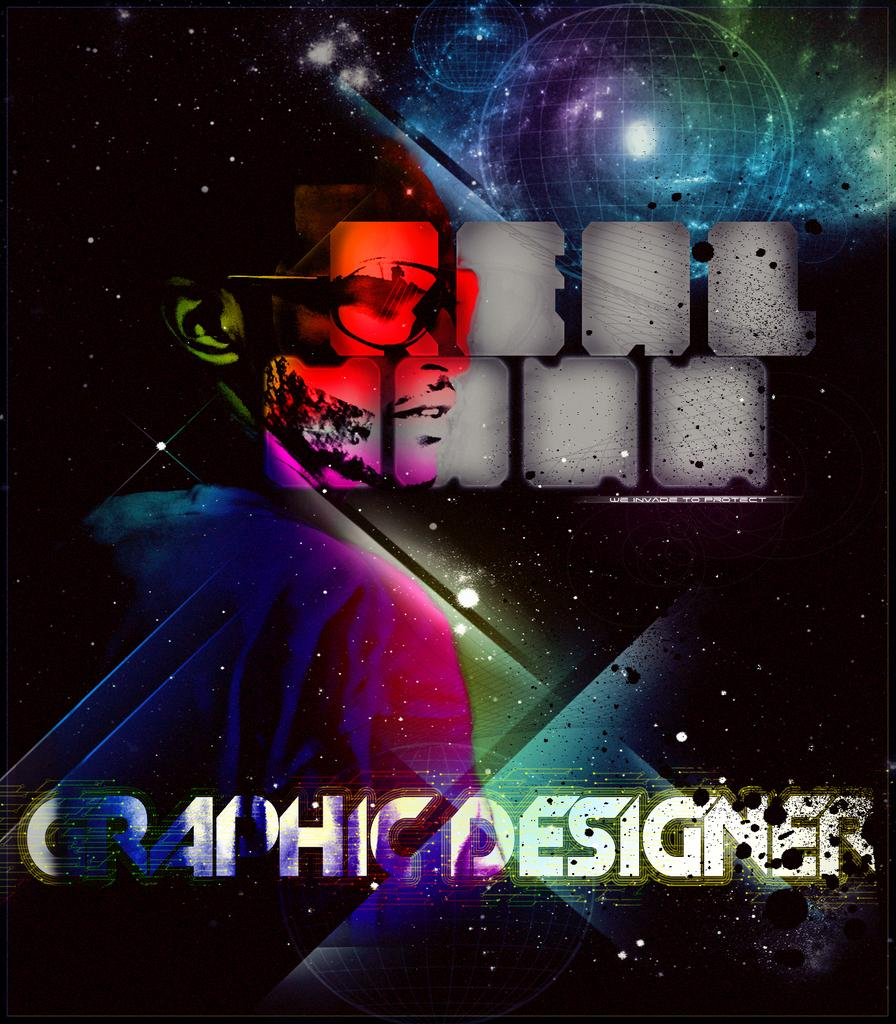What is the main subject of the image? There is a person in the image. Can you describe any additional elements in the image? There is text in the image. What color are the person's eyes in the image? The color of the person's eyes cannot be determined from the image, as there is no mention of their eyes in the provided facts. 